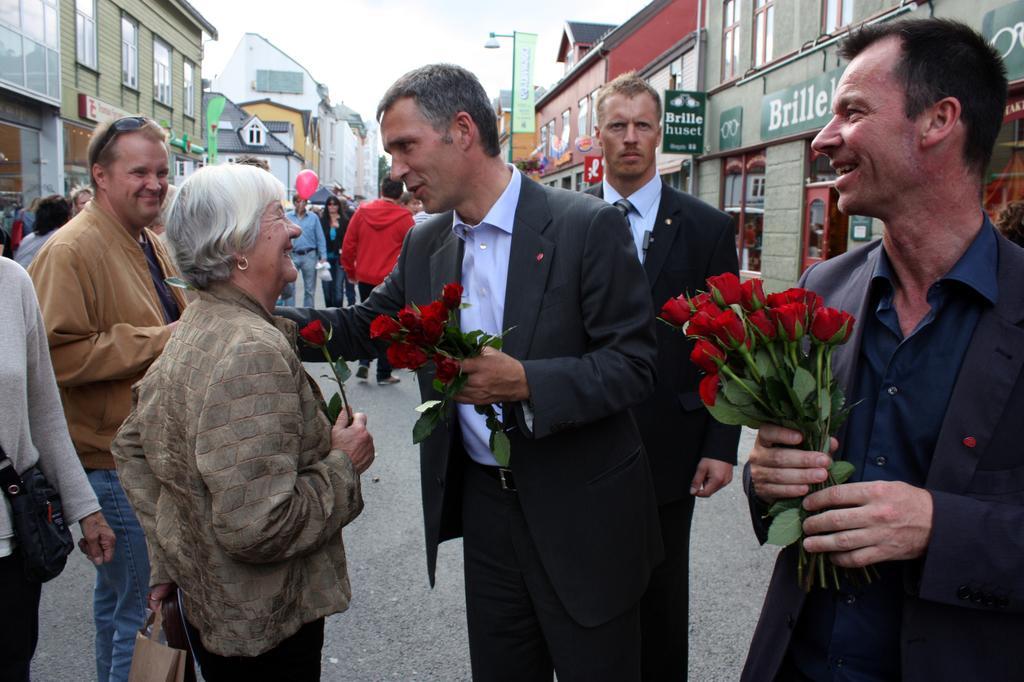Please provide a concise description of this image. In this image I can see two persons are holding rose flowers in their hand and a crowd on the road. In the background I can see buildings, boards, light poles, windows and the sky. This image is taken may be on the road. 